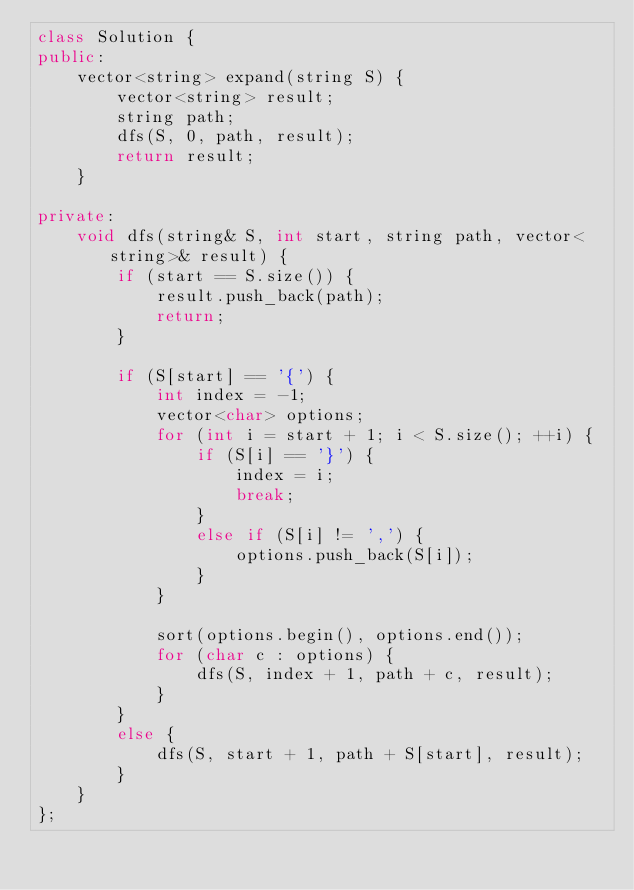<code> <loc_0><loc_0><loc_500><loc_500><_C++_>class Solution {
public:
    vector<string> expand(string S) {
        vector<string> result;
        string path;
        dfs(S, 0, path, result);
        return result;
    }
    
private:
    void dfs(string& S, int start, string path, vector<string>& result) {
        if (start == S.size()) {
            result.push_back(path);
            return;
        }
        
        if (S[start] == '{') {
            int index = -1;
            vector<char> options;
            for (int i = start + 1; i < S.size(); ++i) {
                if (S[i] == '}') {
                    index = i;
                    break;
                }
                else if (S[i] != ',') {
                    options.push_back(S[i]);
                }
            }

            sort(options.begin(), options.end());
            for (char c : options) {
                dfs(S, index + 1, path + c, result);
            }
        }
        else {
            dfs(S, start + 1, path + S[start], result);
        }
    }
};
</code> 